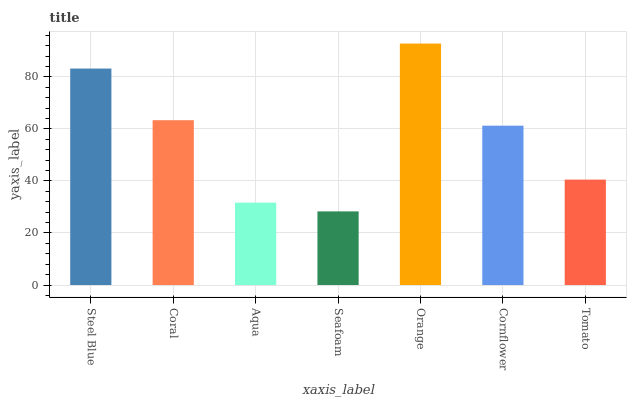Is Seafoam the minimum?
Answer yes or no. Yes. Is Orange the maximum?
Answer yes or no. Yes. Is Coral the minimum?
Answer yes or no. No. Is Coral the maximum?
Answer yes or no. No. Is Steel Blue greater than Coral?
Answer yes or no. Yes. Is Coral less than Steel Blue?
Answer yes or no. Yes. Is Coral greater than Steel Blue?
Answer yes or no. No. Is Steel Blue less than Coral?
Answer yes or no. No. Is Cornflower the high median?
Answer yes or no. Yes. Is Cornflower the low median?
Answer yes or no. Yes. Is Orange the high median?
Answer yes or no. No. Is Aqua the low median?
Answer yes or no. No. 